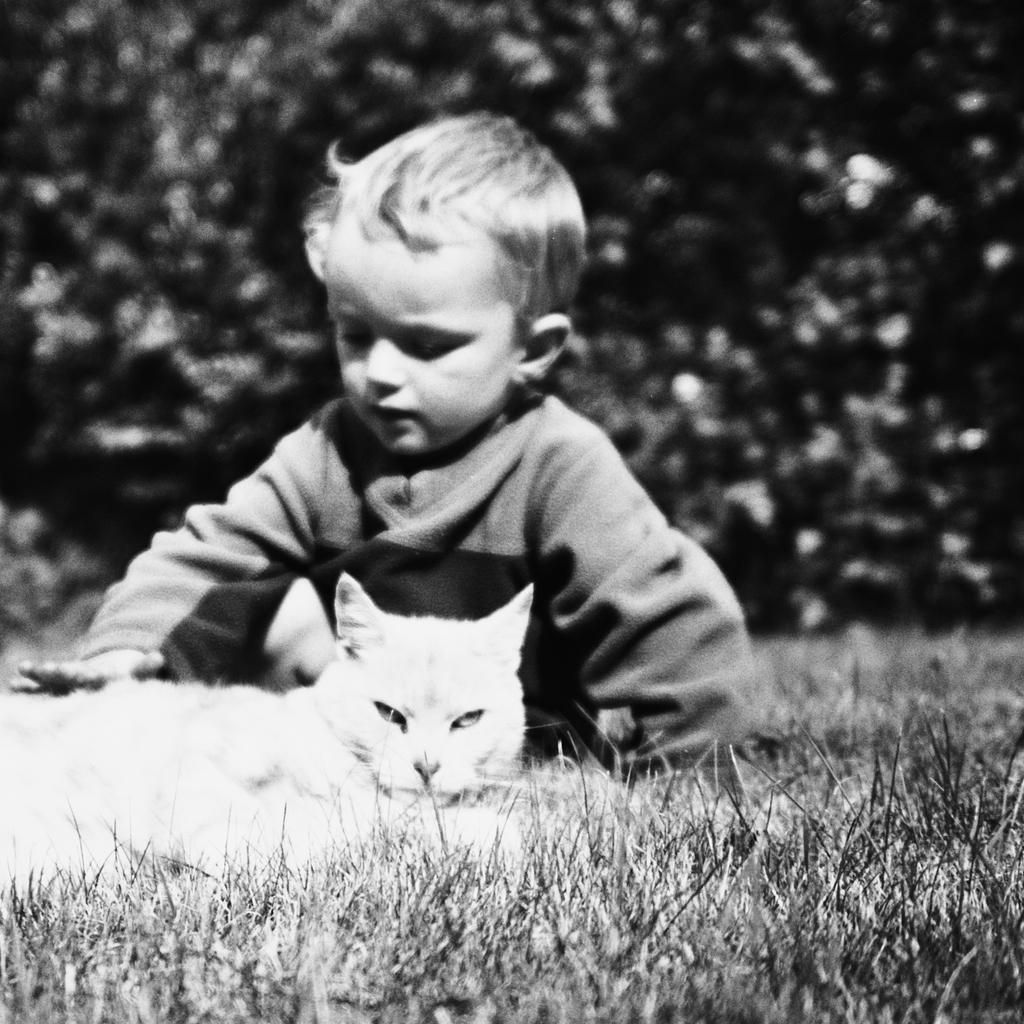Can you describe this image briefly? In this picture there is a little baby and a cat on the grass and behind them there are some trees. 